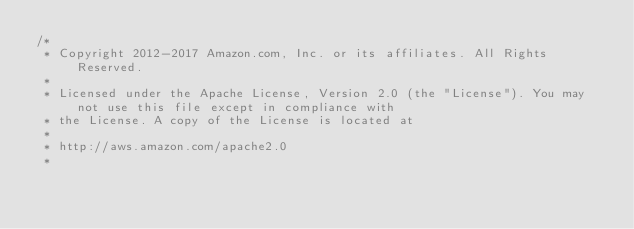<code> <loc_0><loc_0><loc_500><loc_500><_Java_>/*
 * Copyright 2012-2017 Amazon.com, Inc. or its affiliates. All Rights Reserved.
 * 
 * Licensed under the Apache License, Version 2.0 (the "License"). You may not use this file except in compliance with
 * the License. A copy of the License is located at
 * 
 * http://aws.amazon.com/apache2.0
 * </code> 